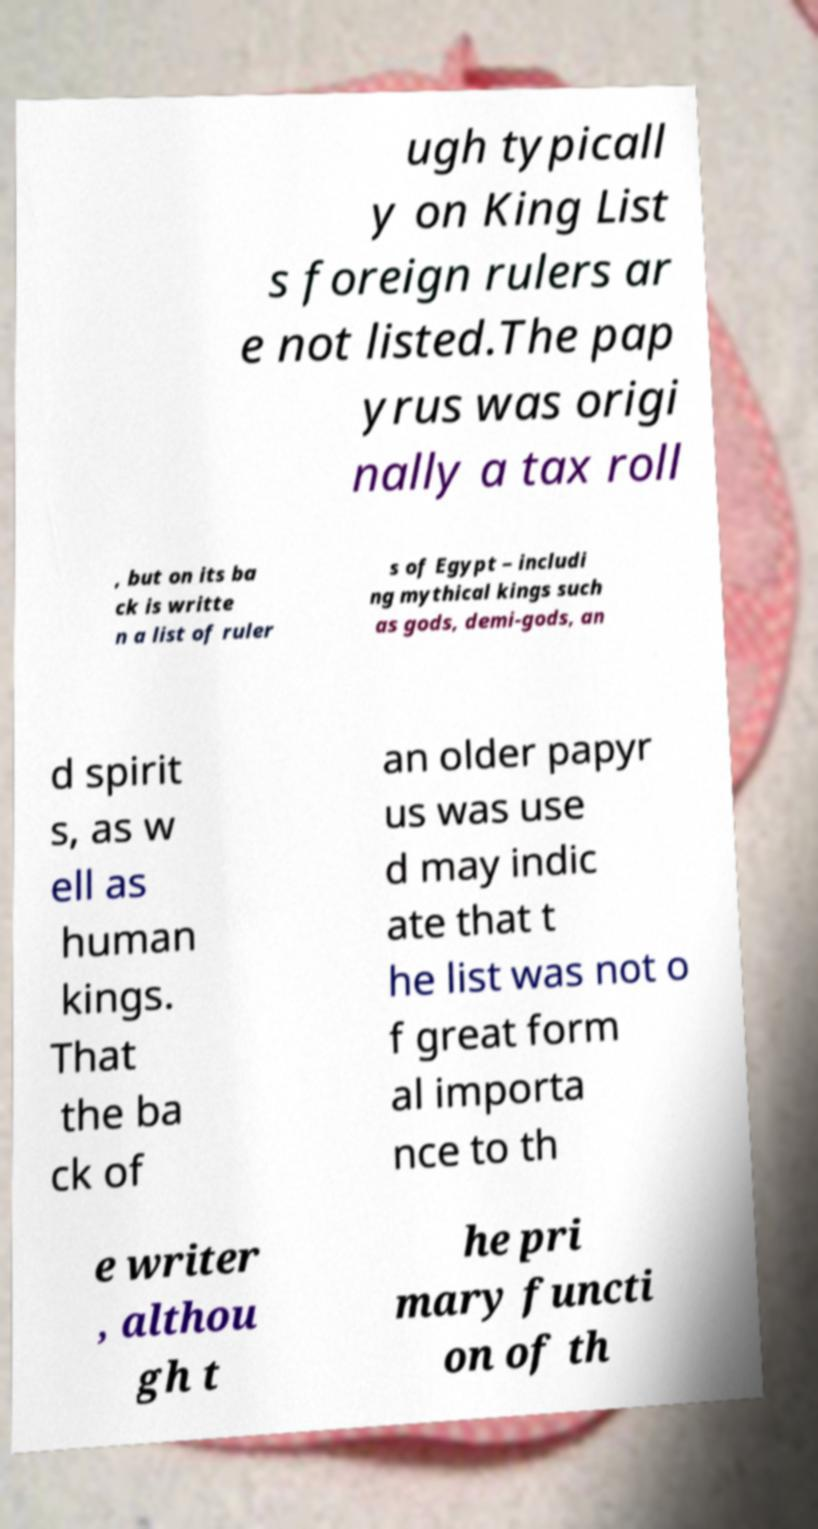For documentation purposes, I need the text within this image transcribed. Could you provide that? ugh typicall y on King List s foreign rulers ar e not listed.The pap yrus was origi nally a tax roll , but on its ba ck is writte n a list of ruler s of Egypt – includi ng mythical kings such as gods, demi-gods, an d spirit s, as w ell as human kings. That the ba ck of an older papyr us was use d may indic ate that t he list was not o f great form al importa nce to th e writer , althou gh t he pri mary functi on of th 